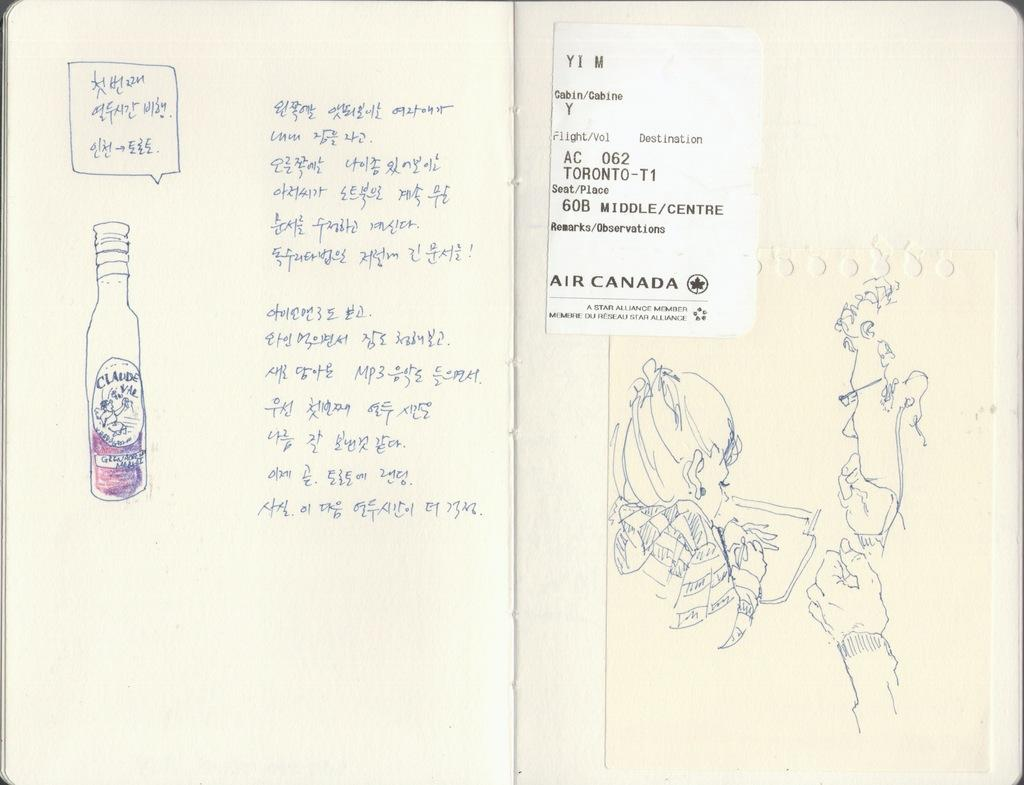<image>
Present a compact description of the photo's key features. A notebook has a sticker with Toronto on it. 